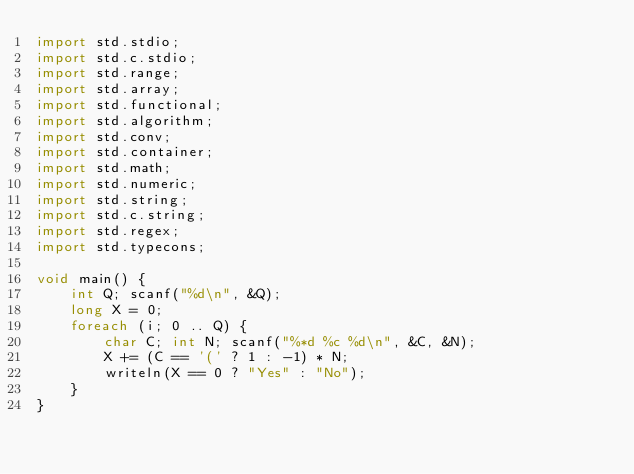<code> <loc_0><loc_0><loc_500><loc_500><_D_>import std.stdio;
import std.c.stdio;
import std.range;
import std.array;
import std.functional;
import std.algorithm;
import std.conv;
import std.container;
import std.math;
import std.numeric;
import std.string;
import std.c.string;
import std.regex;
import std.typecons;
 
void main() {
    int Q; scanf("%d\n", &Q);
    long X = 0;
    foreach (i; 0 .. Q) {
        char C; int N; scanf("%*d %c %d\n", &C, &N);
        X += (C == '(' ? 1 : -1) * N;
        writeln(X == 0 ? "Yes" : "No");
    }
}</code> 